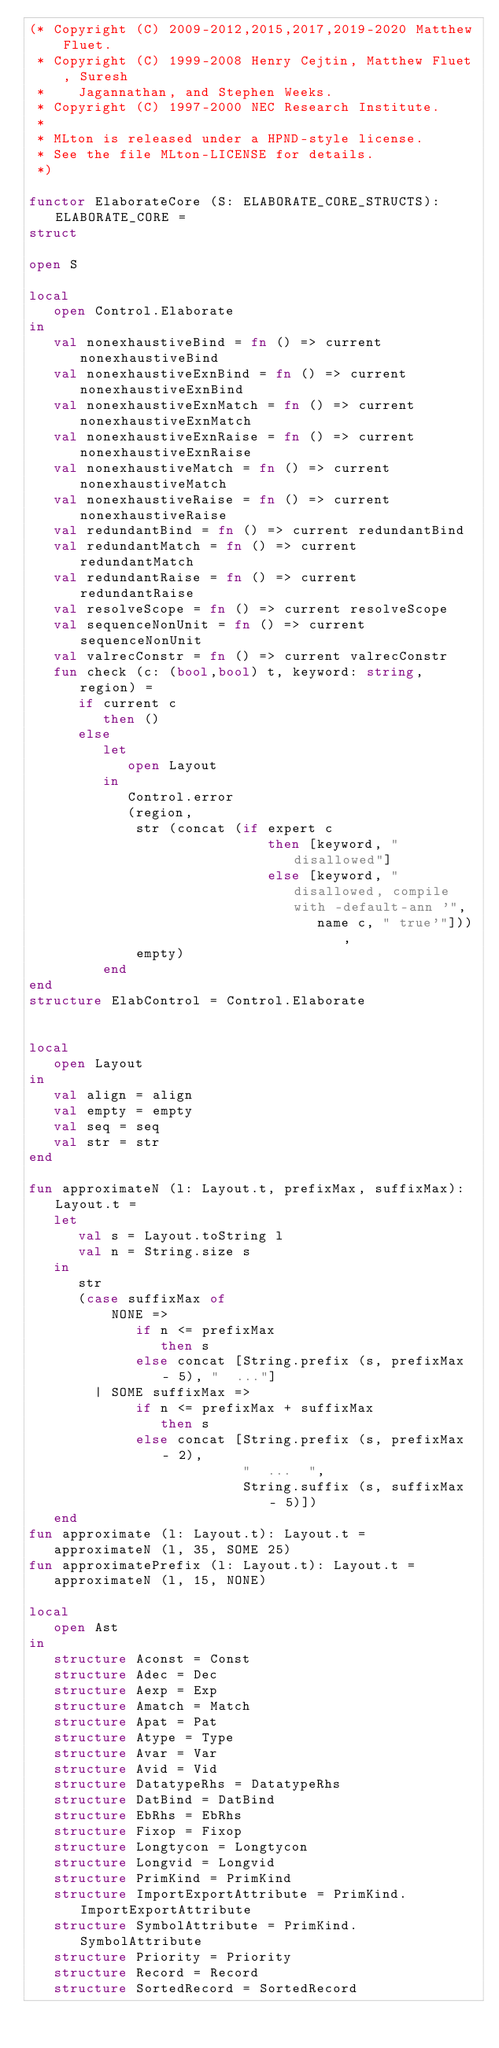Convert code to text. <code><loc_0><loc_0><loc_500><loc_500><_SML_>(* Copyright (C) 2009-2012,2015,2017,2019-2020 Matthew Fluet.
 * Copyright (C) 1999-2008 Henry Cejtin, Matthew Fluet, Suresh
 *    Jagannathan, and Stephen Weeks.
 * Copyright (C) 1997-2000 NEC Research Institute.
 *
 * MLton is released under a HPND-style license.
 * See the file MLton-LICENSE for details.
 *)

functor ElaborateCore (S: ELABORATE_CORE_STRUCTS): ELABORATE_CORE =
struct

open S

local
   open Control.Elaborate
in
   val nonexhaustiveBind = fn () => current nonexhaustiveBind
   val nonexhaustiveExnBind = fn () => current nonexhaustiveExnBind
   val nonexhaustiveExnMatch = fn () => current nonexhaustiveExnMatch
   val nonexhaustiveExnRaise = fn () => current nonexhaustiveExnRaise
   val nonexhaustiveMatch = fn () => current nonexhaustiveMatch
   val nonexhaustiveRaise = fn () => current nonexhaustiveRaise
   val redundantBind = fn () => current redundantBind
   val redundantMatch = fn () => current redundantMatch
   val redundantRaise = fn () => current redundantRaise
   val resolveScope = fn () => current resolveScope
   val sequenceNonUnit = fn () => current sequenceNonUnit
   val valrecConstr = fn () => current valrecConstr
   fun check (c: (bool,bool) t, keyword: string, region) =
      if current c
         then ()
      else
         let
            open Layout
         in
            Control.error
            (region,
             str (concat (if expert c
                             then [keyword, " disallowed"]
                             else [keyword, " disallowed, compile with -default-ann '",
                                   name c, " true'"])),
             empty)
         end
end
structure ElabControl = Control.Elaborate


local
   open Layout
in
   val align = align
   val empty = empty
   val seq = seq
   val str = str
end

fun approximateN (l: Layout.t, prefixMax, suffixMax): Layout.t =
   let
      val s = Layout.toString l
      val n = String.size s
   in
      str
      (case suffixMax of
          NONE =>
             if n <= prefixMax
                then s
             else concat [String.prefix (s, prefixMax - 5), "  ..."]
        | SOME suffixMax =>
             if n <= prefixMax + suffixMax
                then s
             else concat [String.prefix (s, prefixMax - 2),
                          "  ...  ",
                          String.suffix (s, suffixMax - 5)])
   end
fun approximate (l: Layout.t): Layout.t =
   approximateN (l, 35, SOME 25)
fun approximatePrefix (l: Layout.t): Layout.t =
   approximateN (l, 15, NONE)

local
   open Ast
in
   structure Aconst = Const
   structure Adec = Dec
   structure Aexp = Exp
   structure Amatch = Match
   structure Apat = Pat
   structure Atype = Type
   structure Avar = Var
   structure Avid = Vid
   structure DatatypeRhs = DatatypeRhs
   structure DatBind = DatBind
   structure EbRhs = EbRhs
   structure Fixop = Fixop
   structure Longtycon = Longtycon
   structure Longvid = Longvid
   structure PrimKind = PrimKind
   structure ImportExportAttribute = PrimKind.ImportExportAttribute
   structure SymbolAttribute = PrimKind.SymbolAttribute
   structure Priority = Priority
   structure Record = Record
   structure SortedRecord = SortedRecord</code> 